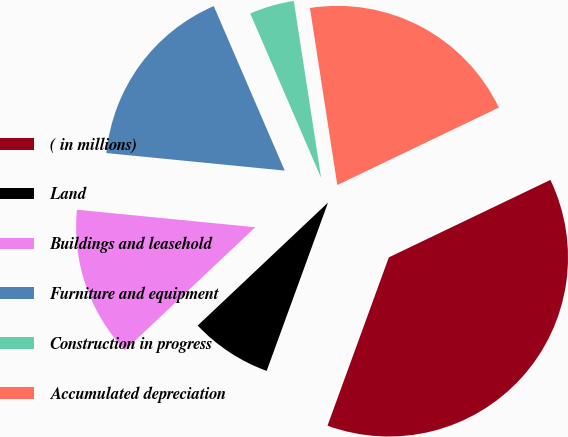<chart> <loc_0><loc_0><loc_500><loc_500><pie_chart><fcel>( in millions)<fcel>Land<fcel>Buildings and leasehold<fcel>Furniture and equipment<fcel>Construction in progress<fcel>Accumulated depreciation<nl><fcel>37.68%<fcel>7.4%<fcel>13.6%<fcel>16.96%<fcel>4.04%<fcel>20.33%<nl></chart> 